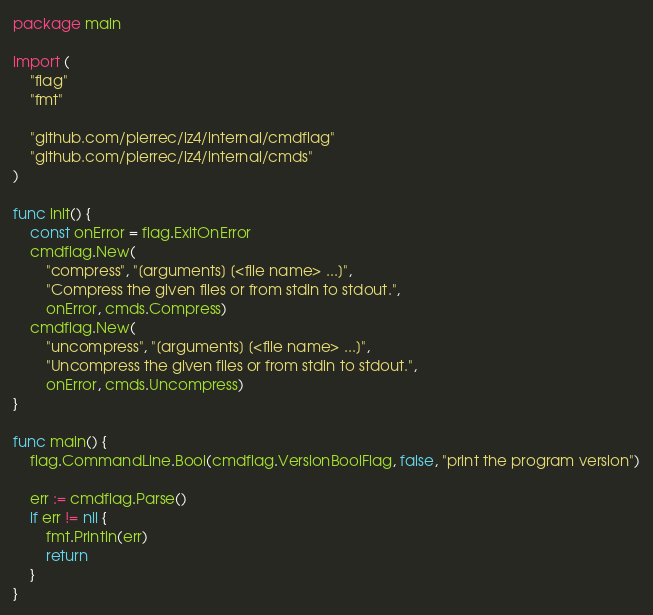Convert code to text. <code><loc_0><loc_0><loc_500><loc_500><_Go_>package main

import (
	"flag"
	"fmt"

	"github.com/pierrec/lz4/internal/cmdflag"
	"github.com/pierrec/lz4/internal/cmds"
)

func init() {
	const onError = flag.ExitOnError
	cmdflag.New(
		"compress", "[arguments] [<file name> ...]",
		"Compress the given files or from stdin to stdout.",
		onError, cmds.Compress)
	cmdflag.New(
		"uncompress", "[arguments] [<file name> ...]",
		"Uncompress the given files or from stdin to stdout.",
		onError, cmds.Uncompress)
}

func main() {
	flag.CommandLine.Bool(cmdflag.VersionBoolFlag, false, "print the program version")

	err := cmdflag.Parse()
	if err != nil {
		fmt.Println(err)
		return
	}
}
</code> 